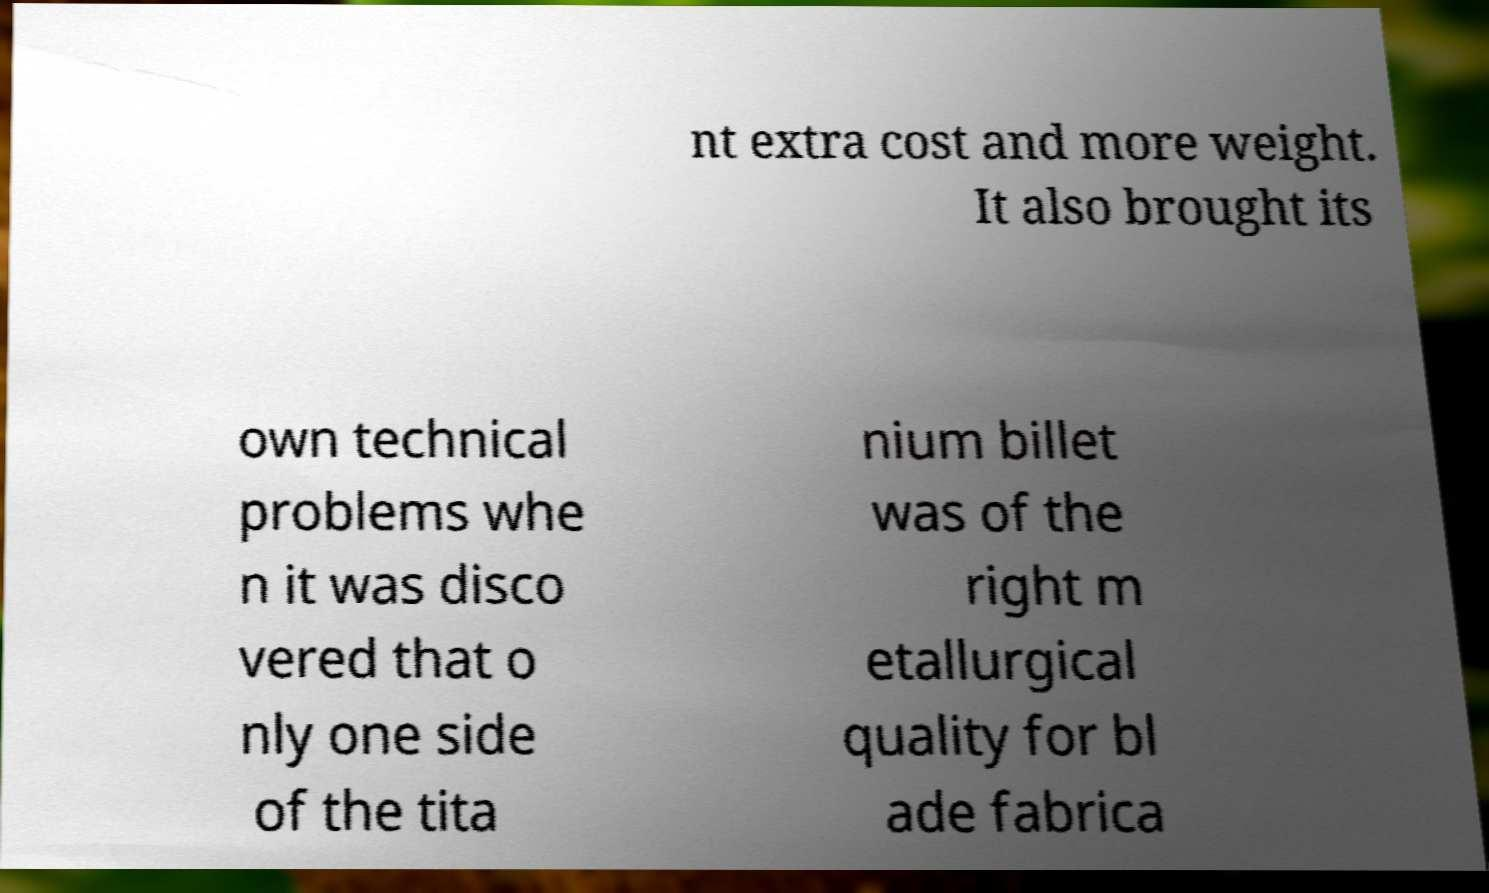I need the written content from this picture converted into text. Can you do that? nt extra cost and more weight. It also brought its own technical problems whe n it was disco vered that o nly one side of the tita nium billet was of the right m etallurgical quality for bl ade fabrica 